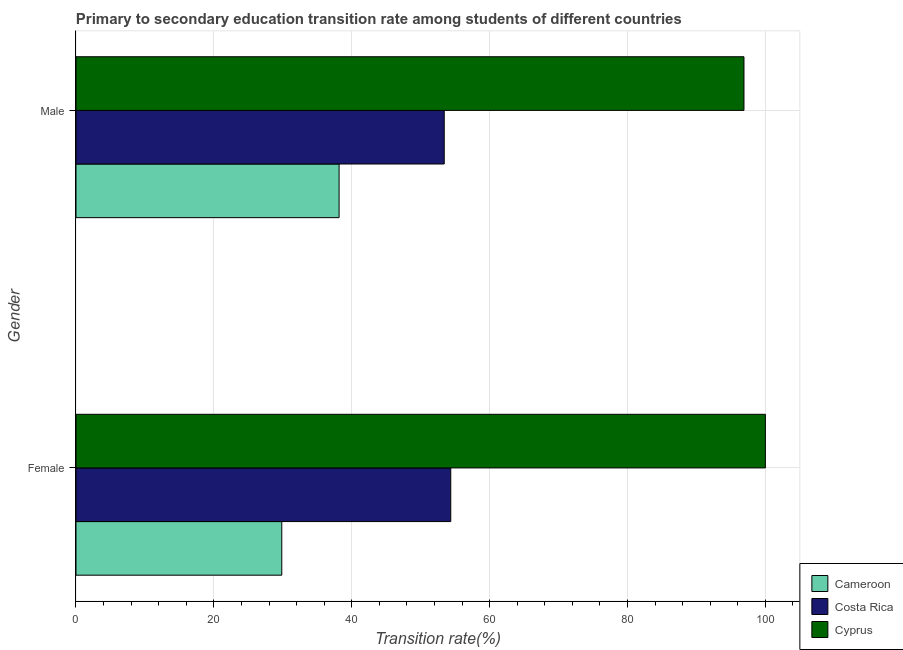How many different coloured bars are there?
Provide a succinct answer. 3. How many groups of bars are there?
Provide a short and direct response. 2. Are the number of bars per tick equal to the number of legend labels?
Give a very brief answer. Yes. Across all countries, what is the maximum transition rate among female students?
Ensure brevity in your answer.  100. Across all countries, what is the minimum transition rate among male students?
Your response must be concise. 38.16. In which country was the transition rate among female students maximum?
Ensure brevity in your answer.  Cyprus. In which country was the transition rate among male students minimum?
Your response must be concise. Cameroon. What is the total transition rate among female students in the graph?
Make the answer very short. 184.21. What is the difference between the transition rate among female students in Cameroon and that in Cyprus?
Provide a short and direct response. -70.15. What is the difference between the transition rate among male students in Cyprus and the transition rate among female students in Cameroon?
Offer a very short reply. 67.04. What is the average transition rate among male students per country?
Your answer should be compact. 62.82. What is the difference between the transition rate among male students and transition rate among female students in Costa Rica?
Provide a succinct answer. -0.94. In how many countries, is the transition rate among female students greater than 88 %?
Offer a terse response. 1. What is the ratio of the transition rate among male students in Cameroon to that in Costa Rica?
Provide a short and direct response. 0.71. What does the 1st bar from the top in Male represents?
Provide a succinct answer. Cyprus. What does the 3rd bar from the bottom in Female represents?
Your response must be concise. Cyprus. How many bars are there?
Your answer should be very brief. 6. Are the values on the major ticks of X-axis written in scientific E-notation?
Provide a short and direct response. No. Does the graph contain any zero values?
Give a very brief answer. No. Where does the legend appear in the graph?
Your response must be concise. Bottom right. How many legend labels are there?
Provide a succinct answer. 3. How are the legend labels stacked?
Give a very brief answer. Vertical. What is the title of the graph?
Keep it short and to the point. Primary to secondary education transition rate among students of different countries. What is the label or title of the X-axis?
Ensure brevity in your answer.  Transition rate(%). What is the label or title of the Y-axis?
Offer a terse response. Gender. What is the Transition rate(%) in Cameroon in Female?
Give a very brief answer. 29.85. What is the Transition rate(%) of Costa Rica in Female?
Give a very brief answer. 54.36. What is the Transition rate(%) in Cameroon in Male?
Give a very brief answer. 38.16. What is the Transition rate(%) of Costa Rica in Male?
Provide a succinct answer. 53.42. What is the Transition rate(%) of Cyprus in Male?
Your answer should be very brief. 96.89. Across all Gender, what is the maximum Transition rate(%) in Cameroon?
Give a very brief answer. 38.16. Across all Gender, what is the maximum Transition rate(%) in Costa Rica?
Your answer should be very brief. 54.36. Across all Gender, what is the maximum Transition rate(%) in Cyprus?
Keep it short and to the point. 100. Across all Gender, what is the minimum Transition rate(%) of Cameroon?
Your answer should be very brief. 29.85. Across all Gender, what is the minimum Transition rate(%) in Costa Rica?
Your answer should be very brief. 53.42. Across all Gender, what is the minimum Transition rate(%) of Cyprus?
Your response must be concise. 96.89. What is the total Transition rate(%) of Cameroon in the graph?
Your answer should be very brief. 68.01. What is the total Transition rate(%) of Costa Rica in the graph?
Your answer should be compact. 107.78. What is the total Transition rate(%) of Cyprus in the graph?
Provide a succinct answer. 196.89. What is the difference between the Transition rate(%) in Cameroon in Female and that in Male?
Your answer should be compact. -8.31. What is the difference between the Transition rate(%) of Cyprus in Female and that in Male?
Give a very brief answer. 3.11. What is the difference between the Transition rate(%) in Cameroon in Female and the Transition rate(%) in Costa Rica in Male?
Your answer should be very brief. -23.57. What is the difference between the Transition rate(%) in Cameroon in Female and the Transition rate(%) in Cyprus in Male?
Keep it short and to the point. -67.04. What is the difference between the Transition rate(%) of Costa Rica in Female and the Transition rate(%) of Cyprus in Male?
Your answer should be very brief. -42.53. What is the average Transition rate(%) of Cameroon per Gender?
Offer a terse response. 34.01. What is the average Transition rate(%) of Costa Rica per Gender?
Offer a terse response. 53.89. What is the average Transition rate(%) of Cyprus per Gender?
Give a very brief answer. 98.45. What is the difference between the Transition rate(%) in Cameroon and Transition rate(%) in Costa Rica in Female?
Make the answer very short. -24.51. What is the difference between the Transition rate(%) of Cameroon and Transition rate(%) of Cyprus in Female?
Your answer should be compact. -70.15. What is the difference between the Transition rate(%) in Costa Rica and Transition rate(%) in Cyprus in Female?
Ensure brevity in your answer.  -45.64. What is the difference between the Transition rate(%) of Cameroon and Transition rate(%) of Costa Rica in Male?
Offer a very short reply. -15.25. What is the difference between the Transition rate(%) in Cameroon and Transition rate(%) in Cyprus in Male?
Your answer should be very brief. -58.73. What is the difference between the Transition rate(%) of Costa Rica and Transition rate(%) of Cyprus in Male?
Give a very brief answer. -43.48. What is the ratio of the Transition rate(%) of Cameroon in Female to that in Male?
Offer a terse response. 0.78. What is the ratio of the Transition rate(%) of Costa Rica in Female to that in Male?
Provide a succinct answer. 1.02. What is the ratio of the Transition rate(%) in Cyprus in Female to that in Male?
Keep it short and to the point. 1.03. What is the difference between the highest and the second highest Transition rate(%) in Cameroon?
Give a very brief answer. 8.31. What is the difference between the highest and the second highest Transition rate(%) of Cyprus?
Make the answer very short. 3.11. What is the difference between the highest and the lowest Transition rate(%) in Cameroon?
Keep it short and to the point. 8.31. What is the difference between the highest and the lowest Transition rate(%) of Cyprus?
Your answer should be compact. 3.11. 